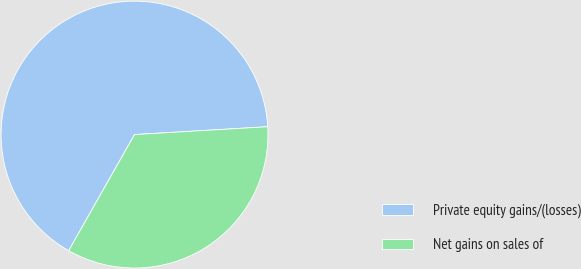Convert chart. <chart><loc_0><loc_0><loc_500><loc_500><pie_chart><fcel>Private equity gains/(losses)<fcel>Net gains on sales of<nl><fcel>65.85%<fcel>34.15%<nl></chart> 